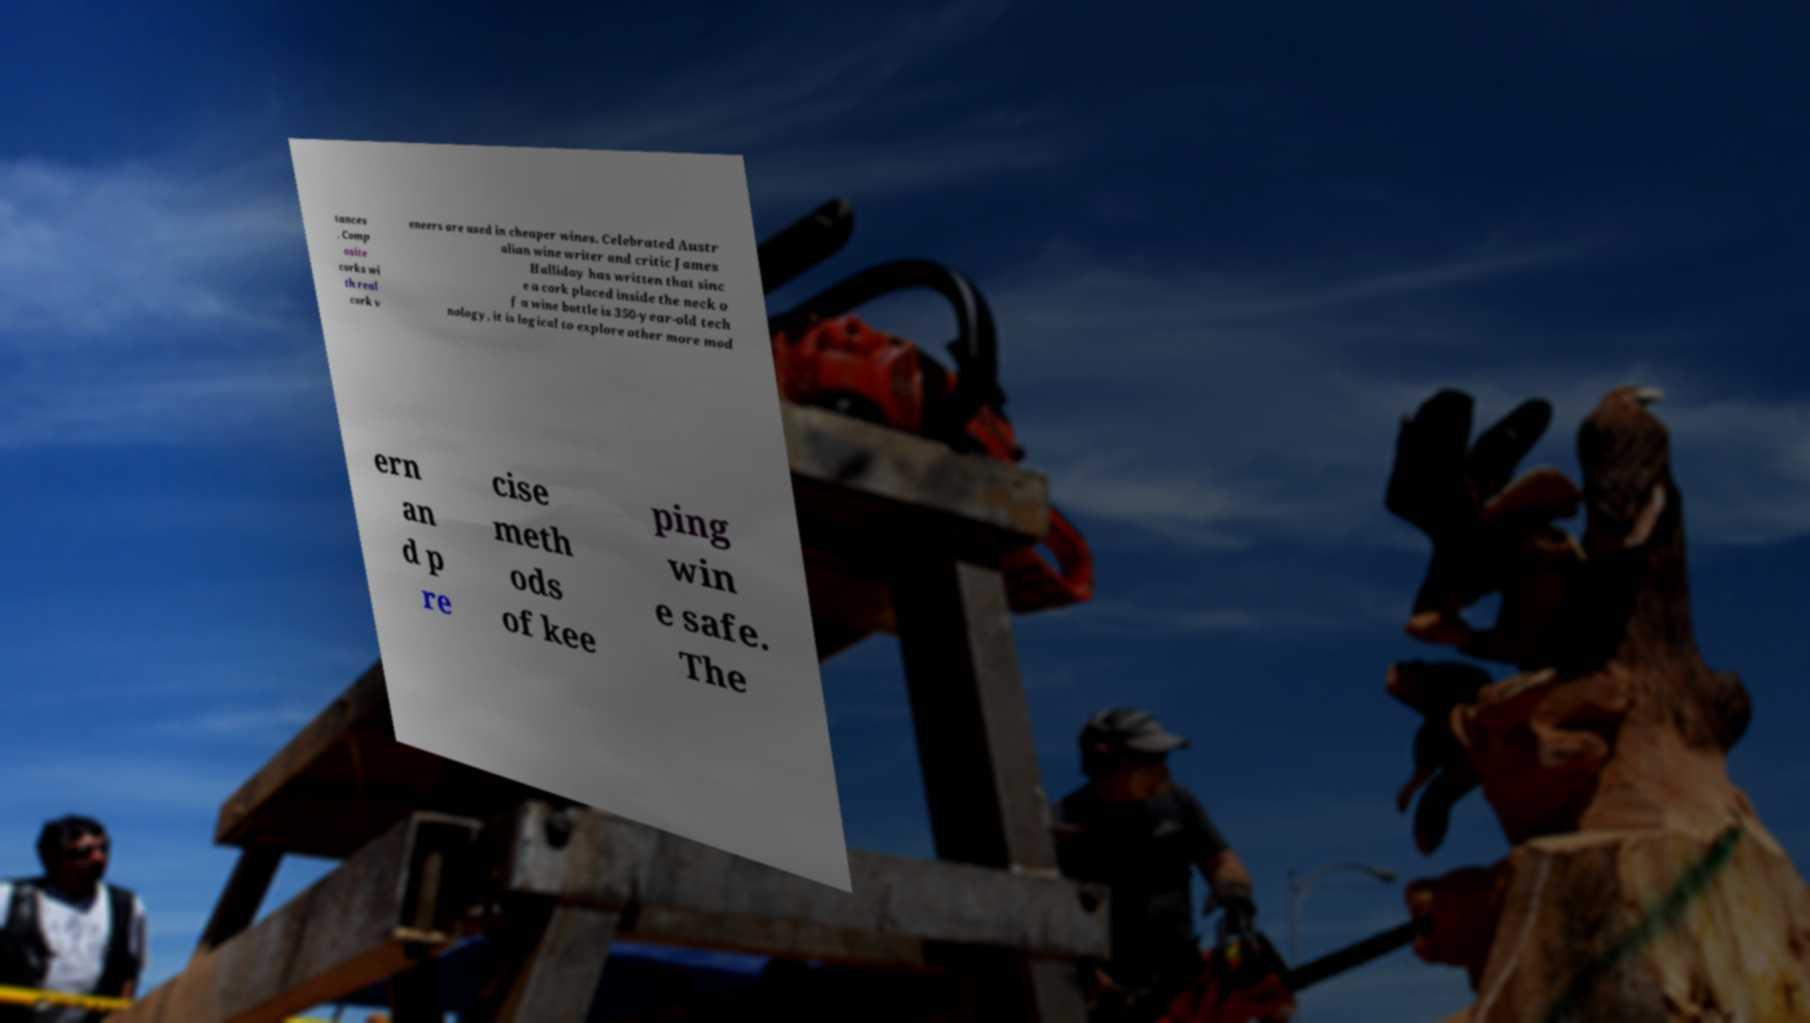There's text embedded in this image that I need extracted. Can you transcribe it verbatim? tances . Comp osite corks wi th real cork v eneers are used in cheaper wines. Celebrated Austr alian wine writer and critic James Halliday has written that sinc e a cork placed inside the neck o f a wine bottle is 350-year-old tech nology, it is logical to explore other more mod ern an d p re cise meth ods of kee ping win e safe. The 